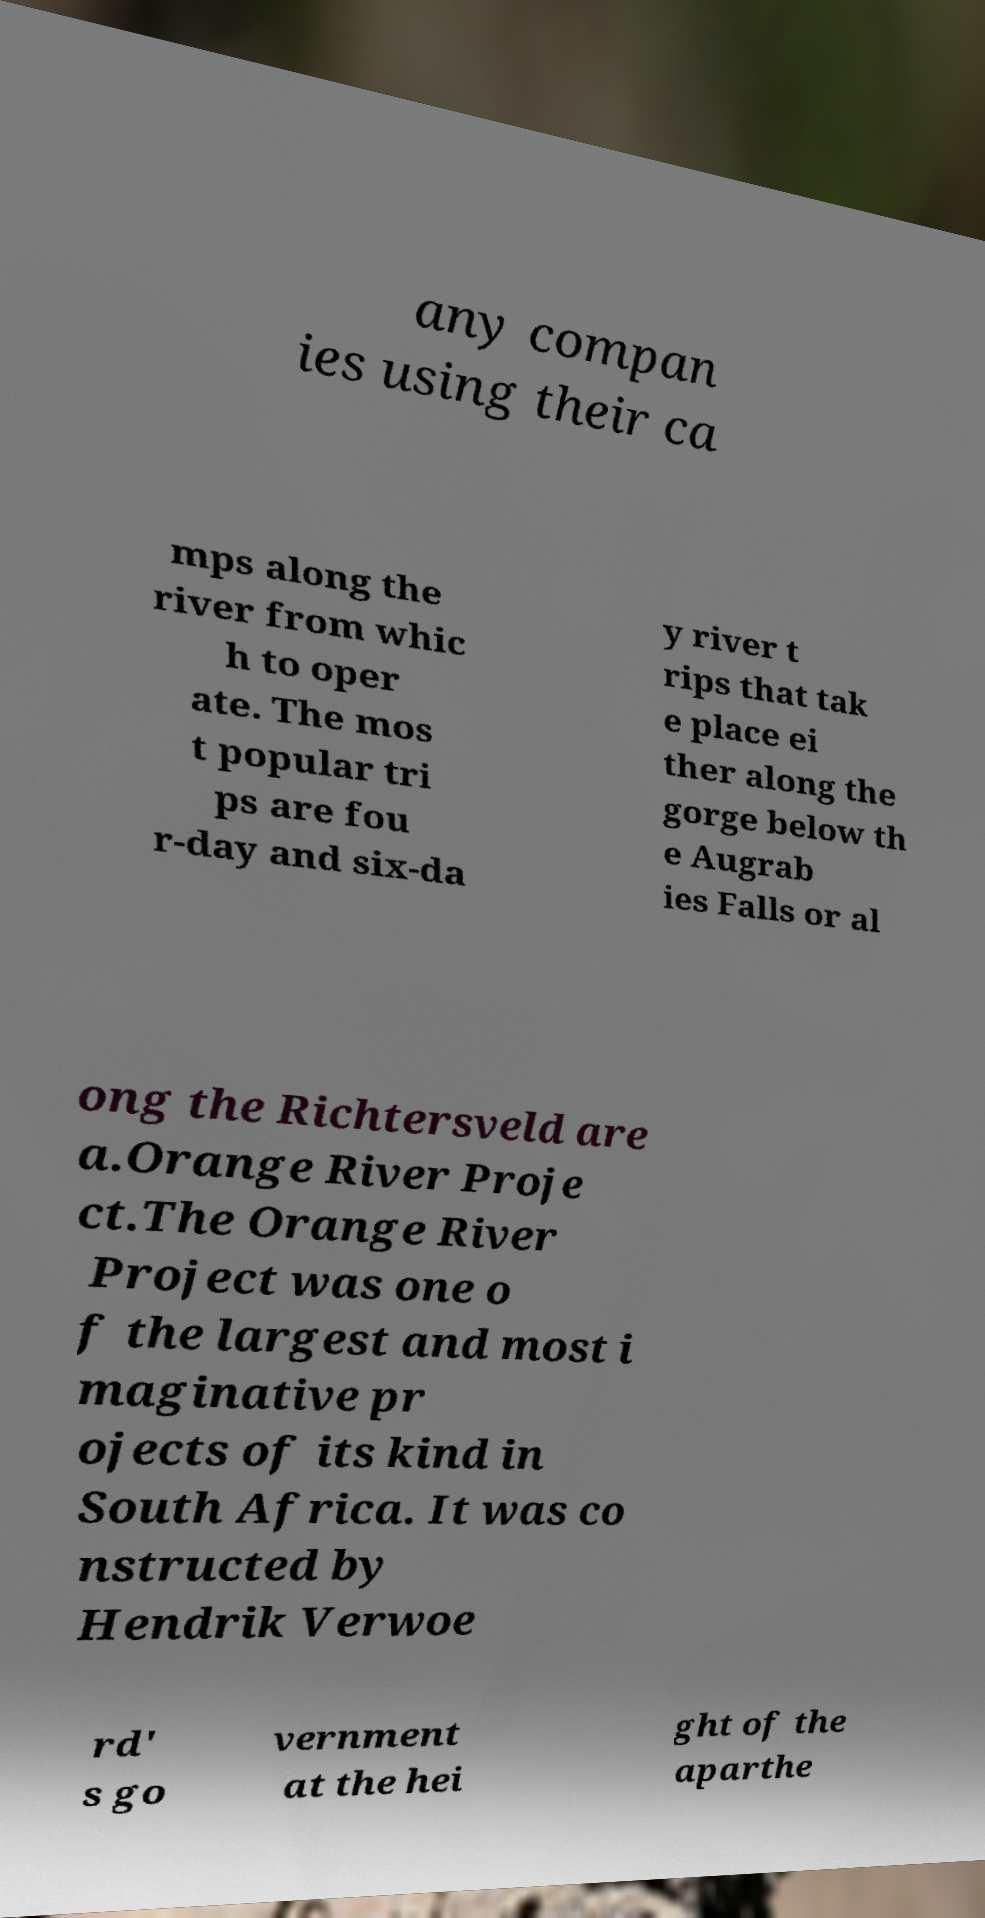Please identify and transcribe the text found in this image. any compan ies using their ca mps along the river from whic h to oper ate. The mos t popular tri ps are fou r-day and six-da y river t rips that tak e place ei ther along the gorge below th e Augrab ies Falls or al ong the Richtersveld are a.Orange River Proje ct.The Orange River Project was one o f the largest and most i maginative pr ojects of its kind in South Africa. It was co nstructed by Hendrik Verwoe rd' s go vernment at the hei ght of the aparthe 